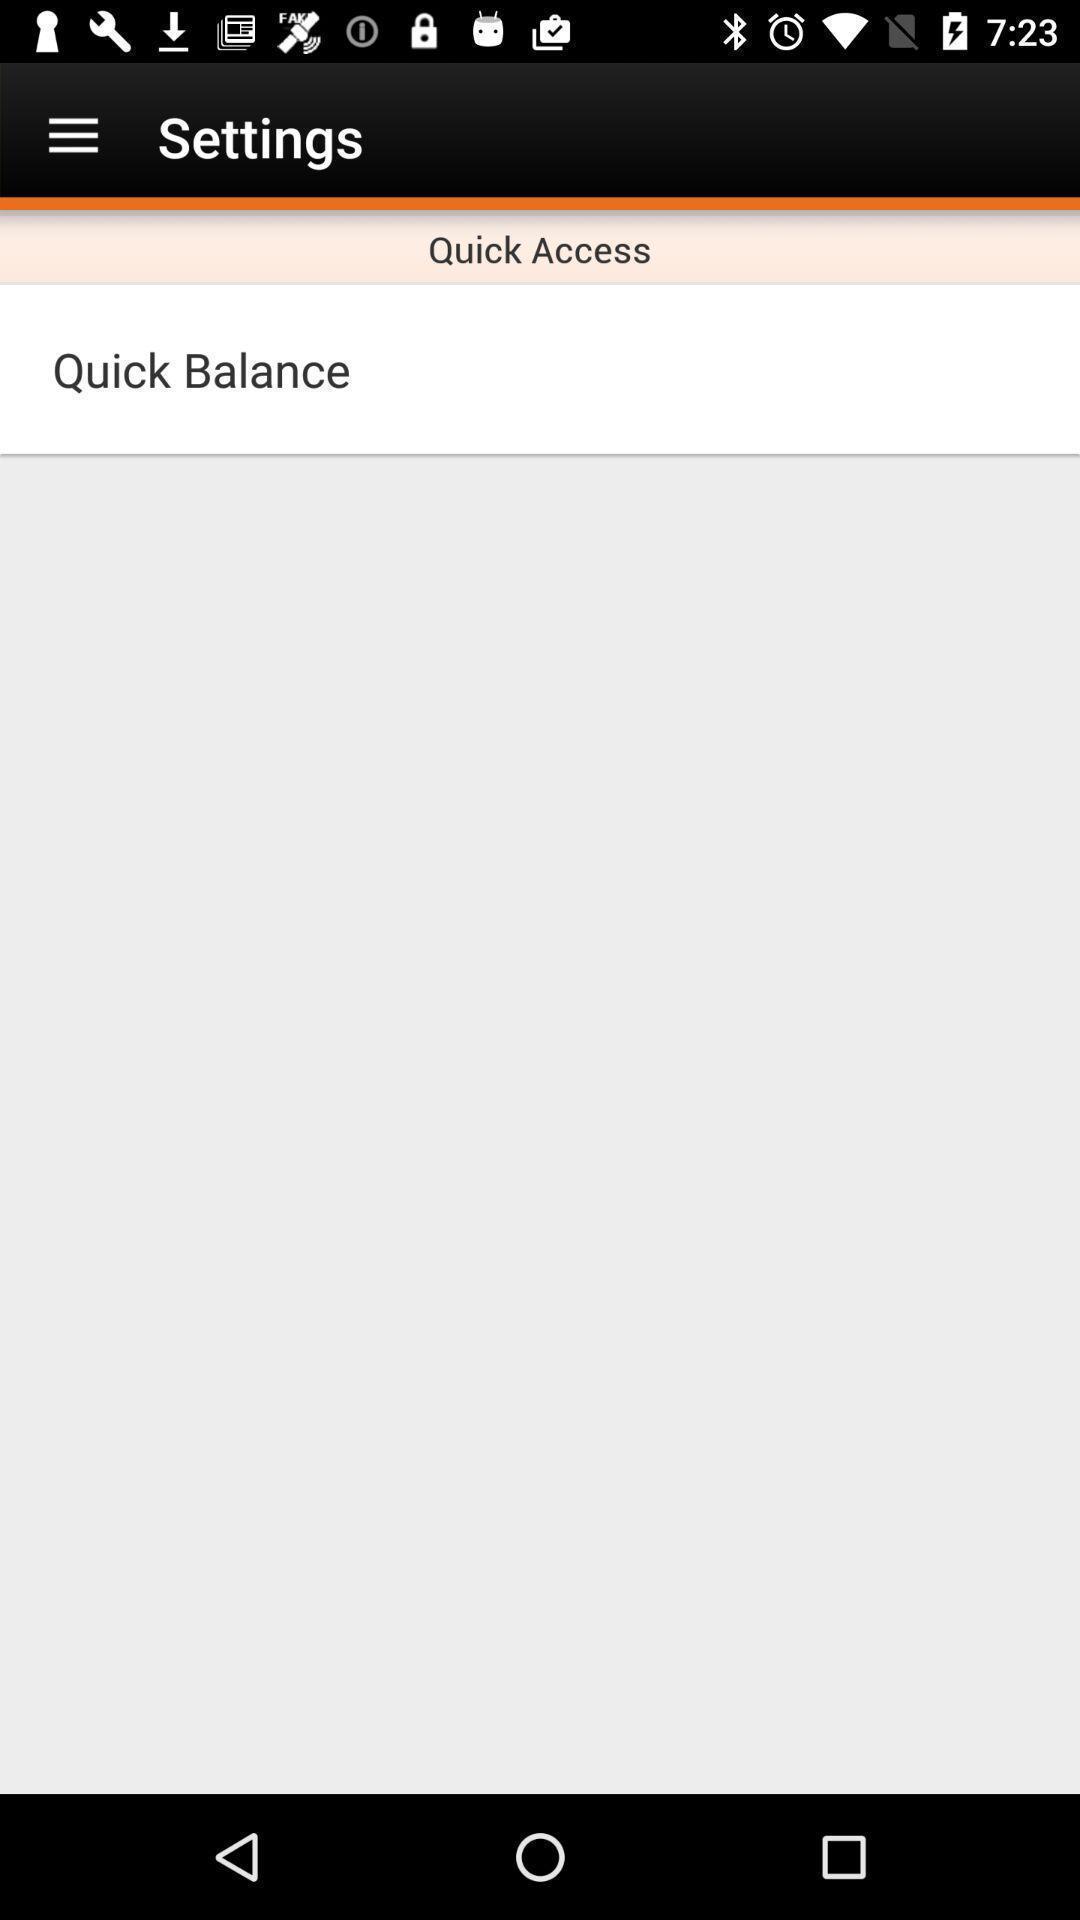Describe this image in words. Settings page showing balance information. 